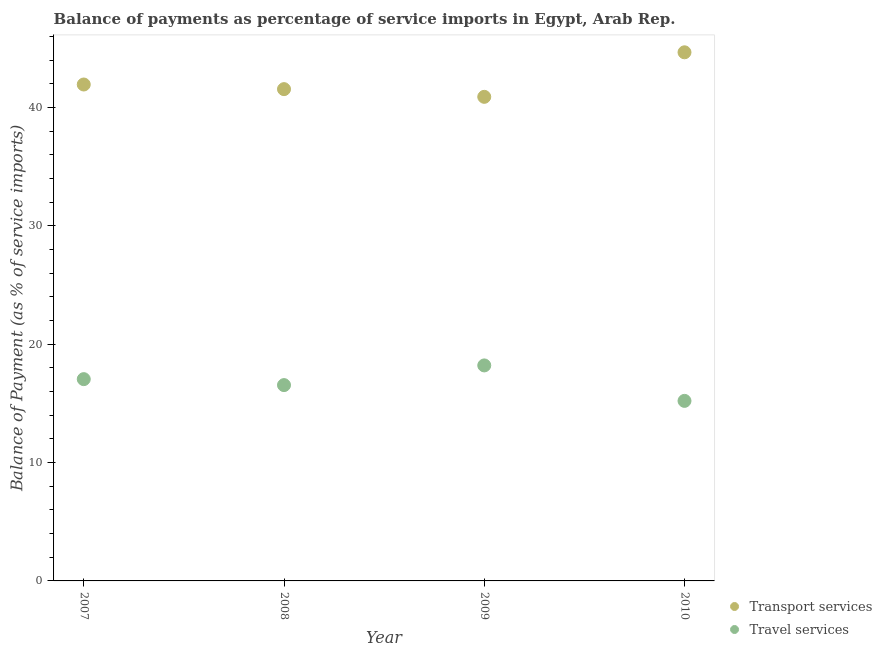Is the number of dotlines equal to the number of legend labels?
Your answer should be compact. Yes. What is the balance of payments of transport services in 2007?
Provide a short and direct response. 41.96. Across all years, what is the maximum balance of payments of travel services?
Keep it short and to the point. 18.21. Across all years, what is the minimum balance of payments of travel services?
Make the answer very short. 15.22. What is the total balance of payments of transport services in the graph?
Your answer should be compact. 169.11. What is the difference between the balance of payments of travel services in 2007 and that in 2009?
Offer a terse response. -1.16. What is the difference between the balance of payments of travel services in 2007 and the balance of payments of transport services in 2008?
Provide a succinct answer. -24.51. What is the average balance of payments of travel services per year?
Give a very brief answer. 16.76. In the year 2007, what is the difference between the balance of payments of travel services and balance of payments of transport services?
Provide a short and direct response. -24.9. In how many years, is the balance of payments of travel services greater than 14 %?
Provide a short and direct response. 4. What is the ratio of the balance of payments of travel services in 2007 to that in 2008?
Offer a terse response. 1.03. What is the difference between the highest and the second highest balance of payments of travel services?
Make the answer very short. 1.16. What is the difference between the highest and the lowest balance of payments of travel services?
Offer a terse response. 3. In how many years, is the balance of payments of transport services greater than the average balance of payments of transport services taken over all years?
Provide a short and direct response. 1. Is the sum of the balance of payments of transport services in 2007 and 2009 greater than the maximum balance of payments of travel services across all years?
Keep it short and to the point. Yes. Is the balance of payments of travel services strictly greater than the balance of payments of transport services over the years?
Your answer should be compact. No. Is the balance of payments of transport services strictly less than the balance of payments of travel services over the years?
Your response must be concise. No. How many years are there in the graph?
Keep it short and to the point. 4. What is the difference between two consecutive major ticks on the Y-axis?
Make the answer very short. 10. Are the values on the major ticks of Y-axis written in scientific E-notation?
Your response must be concise. No. How many legend labels are there?
Your answer should be compact. 2. How are the legend labels stacked?
Give a very brief answer. Vertical. What is the title of the graph?
Ensure brevity in your answer.  Balance of payments as percentage of service imports in Egypt, Arab Rep. Does "Net National savings" appear as one of the legend labels in the graph?
Ensure brevity in your answer.  No. What is the label or title of the Y-axis?
Give a very brief answer. Balance of Payment (as % of service imports). What is the Balance of Payment (as % of service imports) of Transport services in 2007?
Offer a very short reply. 41.96. What is the Balance of Payment (as % of service imports) in Travel services in 2007?
Provide a succinct answer. 17.05. What is the Balance of Payment (as % of service imports) of Transport services in 2008?
Give a very brief answer. 41.56. What is the Balance of Payment (as % of service imports) in Travel services in 2008?
Give a very brief answer. 16.55. What is the Balance of Payment (as % of service imports) of Transport services in 2009?
Offer a very short reply. 40.91. What is the Balance of Payment (as % of service imports) of Travel services in 2009?
Provide a succinct answer. 18.21. What is the Balance of Payment (as % of service imports) of Transport services in 2010?
Give a very brief answer. 44.68. What is the Balance of Payment (as % of service imports) of Travel services in 2010?
Your response must be concise. 15.22. Across all years, what is the maximum Balance of Payment (as % of service imports) of Transport services?
Make the answer very short. 44.68. Across all years, what is the maximum Balance of Payment (as % of service imports) in Travel services?
Your answer should be very brief. 18.21. Across all years, what is the minimum Balance of Payment (as % of service imports) in Transport services?
Provide a short and direct response. 40.91. Across all years, what is the minimum Balance of Payment (as % of service imports) of Travel services?
Offer a terse response. 15.22. What is the total Balance of Payment (as % of service imports) of Transport services in the graph?
Offer a terse response. 169.11. What is the total Balance of Payment (as % of service imports) in Travel services in the graph?
Your answer should be very brief. 67.03. What is the difference between the Balance of Payment (as % of service imports) of Transport services in 2007 and that in 2008?
Give a very brief answer. 0.39. What is the difference between the Balance of Payment (as % of service imports) of Travel services in 2007 and that in 2008?
Offer a terse response. 0.5. What is the difference between the Balance of Payment (as % of service imports) in Transport services in 2007 and that in 2009?
Ensure brevity in your answer.  1.04. What is the difference between the Balance of Payment (as % of service imports) of Travel services in 2007 and that in 2009?
Offer a very short reply. -1.16. What is the difference between the Balance of Payment (as % of service imports) in Transport services in 2007 and that in 2010?
Offer a very short reply. -2.72. What is the difference between the Balance of Payment (as % of service imports) in Travel services in 2007 and that in 2010?
Your answer should be very brief. 1.84. What is the difference between the Balance of Payment (as % of service imports) in Transport services in 2008 and that in 2009?
Provide a short and direct response. 0.65. What is the difference between the Balance of Payment (as % of service imports) of Travel services in 2008 and that in 2009?
Your answer should be compact. -1.66. What is the difference between the Balance of Payment (as % of service imports) in Transport services in 2008 and that in 2010?
Provide a short and direct response. -3.11. What is the difference between the Balance of Payment (as % of service imports) in Travel services in 2008 and that in 2010?
Offer a terse response. 1.33. What is the difference between the Balance of Payment (as % of service imports) of Transport services in 2009 and that in 2010?
Offer a very short reply. -3.76. What is the difference between the Balance of Payment (as % of service imports) in Travel services in 2009 and that in 2010?
Make the answer very short. 3. What is the difference between the Balance of Payment (as % of service imports) of Transport services in 2007 and the Balance of Payment (as % of service imports) of Travel services in 2008?
Your answer should be compact. 25.41. What is the difference between the Balance of Payment (as % of service imports) in Transport services in 2007 and the Balance of Payment (as % of service imports) in Travel services in 2009?
Your answer should be compact. 23.74. What is the difference between the Balance of Payment (as % of service imports) of Transport services in 2007 and the Balance of Payment (as % of service imports) of Travel services in 2010?
Offer a very short reply. 26.74. What is the difference between the Balance of Payment (as % of service imports) in Transport services in 2008 and the Balance of Payment (as % of service imports) in Travel services in 2009?
Your answer should be very brief. 23.35. What is the difference between the Balance of Payment (as % of service imports) in Transport services in 2008 and the Balance of Payment (as % of service imports) in Travel services in 2010?
Make the answer very short. 26.35. What is the difference between the Balance of Payment (as % of service imports) in Transport services in 2009 and the Balance of Payment (as % of service imports) in Travel services in 2010?
Provide a succinct answer. 25.7. What is the average Balance of Payment (as % of service imports) of Transport services per year?
Your answer should be compact. 42.28. What is the average Balance of Payment (as % of service imports) of Travel services per year?
Offer a very short reply. 16.76. In the year 2007, what is the difference between the Balance of Payment (as % of service imports) in Transport services and Balance of Payment (as % of service imports) in Travel services?
Keep it short and to the point. 24.9. In the year 2008, what is the difference between the Balance of Payment (as % of service imports) in Transport services and Balance of Payment (as % of service imports) in Travel services?
Your answer should be very brief. 25.01. In the year 2009, what is the difference between the Balance of Payment (as % of service imports) in Transport services and Balance of Payment (as % of service imports) in Travel services?
Provide a succinct answer. 22.7. In the year 2010, what is the difference between the Balance of Payment (as % of service imports) of Transport services and Balance of Payment (as % of service imports) of Travel services?
Your answer should be compact. 29.46. What is the ratio of the Balance of Payment (as % of service imports) of Transport services in 2007 to that in 2008?
Provide a short and direct response. 1.01. What is the ratio of the Balance of Payment (as % of service imports) in Travel services in 2007 to that in 2008?
Your answer should be compact. 1.03. What is the ratio of the Balance of Payment (as % of service imports) of Transport services in 2007 to that in 2009?
Keep it short and to the point. 1.03. What is the ratio of the Balance of Payment (as % of service imports) of Travel services in 2007 to that in 2009?
Your answer should be compact. 0.94. What is the ratio of the Balance of Payment (as % of service imports) of Transport services in 2007 to that in 2010?
Make the answer very short. 0.94. What is the ratio of the Balance of Payment (as % of service imports) in Travel services in 2007 to that in 2010?
Offer a terse response. 1.12. What is the ratio of the Balance of Payment (as % of service imports) of Transport services in 2008 to that in 2009?
Offer a terse response. 1.02. What is the ratio of the Balance of Payment (as % of service imports) of Travel services in 2008 to that in 2009?
Your answer should be very brief. 0.91. What is the ratio of the Balance of Payment (as % of service imports) of Transport services in 2008 to that in 2010?
Offer a very short reply. 0.93. What is the ratio of the Balance of Payment (as % of service imports) of Travel services in 2008 to that in 2010?
Offer a terse response. 1.09. What is the ratio of the Balance of Payment (as % of service imports) of Transport services in 2009 to that in 2010?
Provide a succinct answer. 0.92. What is the ratio of the Balance of Payment (as % of service imports) in Travel services in 2009 to that in 2010?
Provide a succinct answer. 1.2. What is the difference between the highest and the second highest Balance of Payment (as % of service imports) of Transport services?
Your answer should be compact. 2.72. What is the difference between the highest and the second highest Balance of Payment (as % of service imports) of Travel services?
Your response must be concise. 1.16. What is the difference between the highest and the lowest Balance of Payment (as % of service imports) in Transport services?
Make the answer very short. 3.76. What is the difference between the highest and the lowest Balance of Payment (as % of service imports) in Travel services?
Ensure brevity in your answer.  3. 